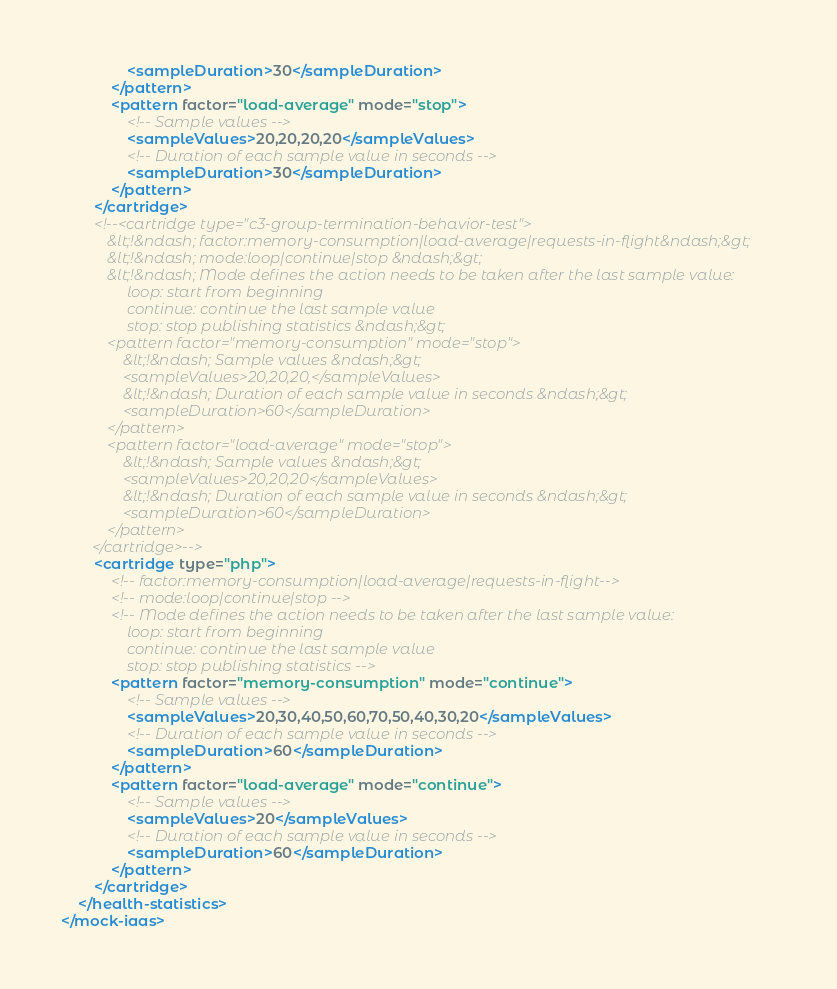<code> <loc_0><loc_0><loc_500><loc_500><_XML_>                <sampleDuration>30</sampleDuration>
            </pattern>
            <pattern factor="load-average" mode="stop">
                <!-- Sample values -->
                <sampleValues>20,20,20,20</sampleValues>
                <!-- Duration of each sample value in seconds -->
                <sampleDuration>30</sampleDuration>
            </pattern>
        </cartridge>
        <!--<cartridge type="c3-group-termination-behavior-test">
            &lt;!&ndash; factor:memory-consumption|load-average|requests-in-flight&ndash;&gt;
            &lt;!&ndash; mode:loop|continue|stop &ndash;&gt;
            &lt;!&ndash; Mode defines the action needs to be taken after the last sample value:
                 loop: start from beginning
                 continue: continue the last sample value
                 stop: stop publishing statistics &ndash;&gt;
            <pattern factor="memory-consumption" mode="stop">
                &lt;!&ndash; Sample values &ndash;&gt;
                <sampleValues>20,20,20,</sampleValues>
                &lt;!&ndash; Duration of each sample value in seconds &ndash;&gt;
                <sampleDuration>60</sampleDuration>
            </pattern>
            <pattern factor="load-average" mode="stop">
                &lt;!&ndash; Sample values &ndash;&gt;
                <sampleValues>20,20,20</sampleValues>
                &lt;!&ndash; Duration of each sample value in seconds &ndash;&gt;
                <sampleDuration>60</sampleDuration>
            </pattern>
        </cartridge>-->
        <cartridge type="php">
            <!-- factor:memory-consumption|load-average|requests-in-flight-->
            <!-- mode:loop|continue|stop -->
            <!-- Mode defines the action needs to be taken after the last sample value:
                 loop: start from beginning
                 continue: continue the last sample value
                 stop: stop publishing statistics -->
            <pattern factor="memory-consumption" mode="continue">
                <!-- Sample values -->
                <sampleValues>20,30,40,50,60,70,50,40,30,20</sampleValues>
                <!-- Duration of each sample value in seconds -->
                <sampleDuration>60</sampleDuration>
            </pattern>
            <pattern factor="load-average" mode="continue">
                <!-- Sample values -->
                <sampleValues>20</sampleValues>
                <!-- Duration of each sample value in seconds -->
                <sampleDuration>60</sampleDuration>
            </pattern>
        </cartridge>
    </health-statistics>
</mock-iaas>
</code> 